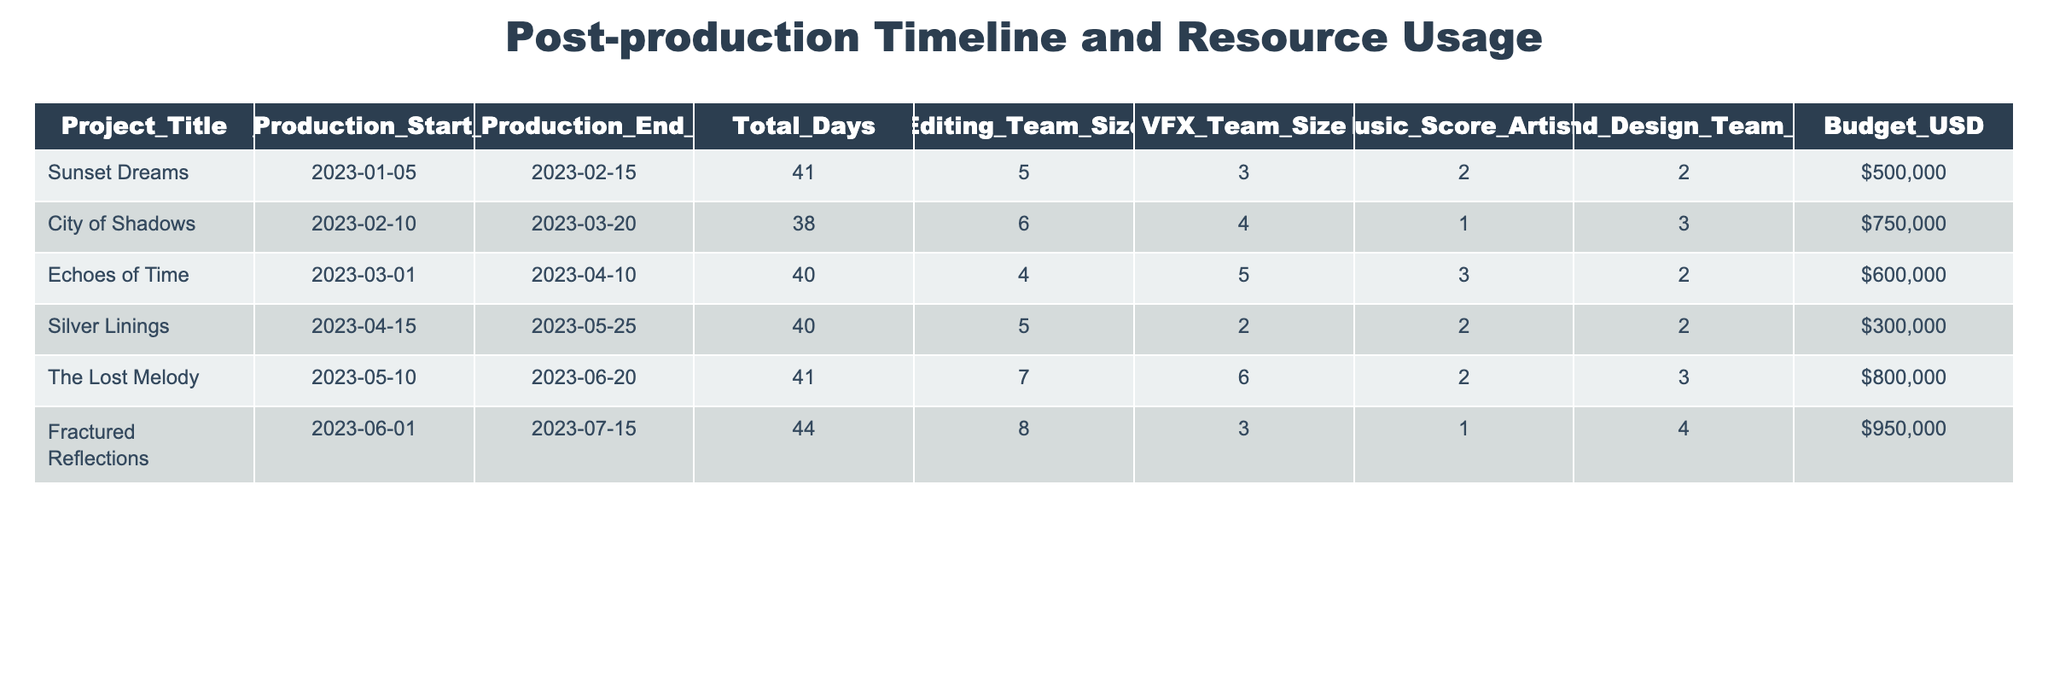What is the total budget allocated for "Fractured Reflections"? The budget allocated for "Fractured Reflections" is listed in the table under the Budget_USD column, which shows a value of $950,000.
Answer: $950,000 What was the editing team size for "City of Shadows"? The table specifies the Editing_Team_Size for "City of Shadows" as 6 members.
Answer: 6 Is "Silver Linings" longer in post-production than "Echoes of Time"? The total days for "Silver Linings" is 40 days and for "Echoes of Time" is 40 days as well. Since their durations are equal, "Silver Linings" is not longer than "Echoes of Time".
Answer: No What is the average budget of all the projects listed? To find the average, sum up all the budgets: 500,000 + 750,000 + 600,000 + 300,000 + 800,000 + 950,000 = 3,900,000. Dividing by the number of projects (6), we get 3,900,000 / 6 = 650,000.
Answer: $650,000 Which project had the largest size of the VFX team? The table shows that "The Lost Melody" had the largest VFX_Team_Size of 6 members, compared to others.
Answer: The Lost Melody What is the total team size for the post-production of "Sunset Dreams"? The total team size can be calculated by adding all team sizes: Editing_Team_Size (5) + VFX_Team_Size (3) + Music_Score_Artists (2) + Sound_Design_Team_Size (2) = 12.
Answer: 12 Did "Echoes of Time" have a sound design team larger than 2? Referring to the data, "Echoes of Time" has a Sound_Design_Team_Size of 2, so it did not exceed that number.
Answer: No What is the difference in post-production days between "Practical Reflections" and "City of Shadows"? "Fractured Reflections" has 44 days and "City of Shadows" has 38 days. The difference is 44 - 38 = 6 days.
Answer: 6 days How many projects had a budget greater than $700,000? Counting the projects with budgets greater than $700,000: "City of Shadows" ($750,000), "The Lost Melody" ($800,000), and "Fractured Reflections" ($950,000), gives a total of 3 projects.
Answer: 3 